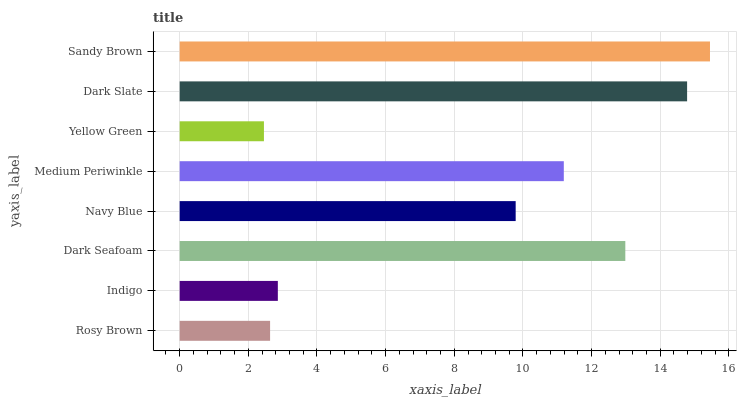Is Yellow Green the minimum?
Answer yes or no. Yes. Is Sandy Brown the maximum?
Answer yes or no. Yes. Is Indigo the minimum?
Answer yes or no. No. Is Indigo the maximum?
Answer yes or no. No. Is Indigo greater than Rosy Brown?
Answer yes or no. Yes. Is Rosy Brown less than Indigo?
Answer yes or no. Yes. Is Rosy Brown greater than Indigo?
Answer yes or no. No. Is Indigo less than Rosy Brown?
Answer yes or no. No. Is Medium Periwinkle the high median?
Answer yes or no. Yes. Is Navy Blue the low median?
Answer yes or no. Yes. Is Navy Blue the high median?
Answer yes or no. No. Is Medium Periwinkle the low median?
Answer yes or no. No. 